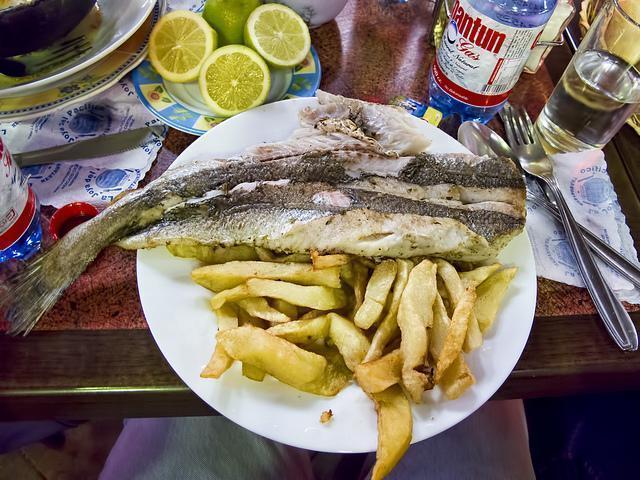What country's citizens are famous for eating this food combination?
Select the accurate response from the four choices given to answer the question.
Options: South africa, philippines, fiji, england. England. 